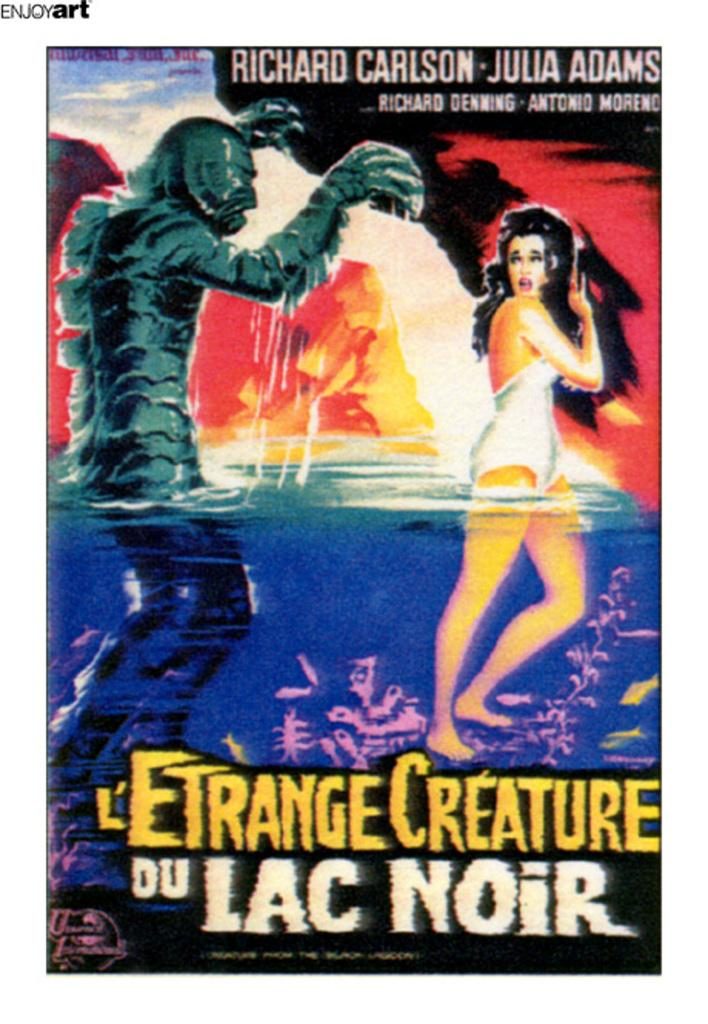<image>
Create a compact narrative representing the image presented. A poster shows Richard Carlson and Julia Adams are the stars of L'Entrange Creature Du Lac Noir. 